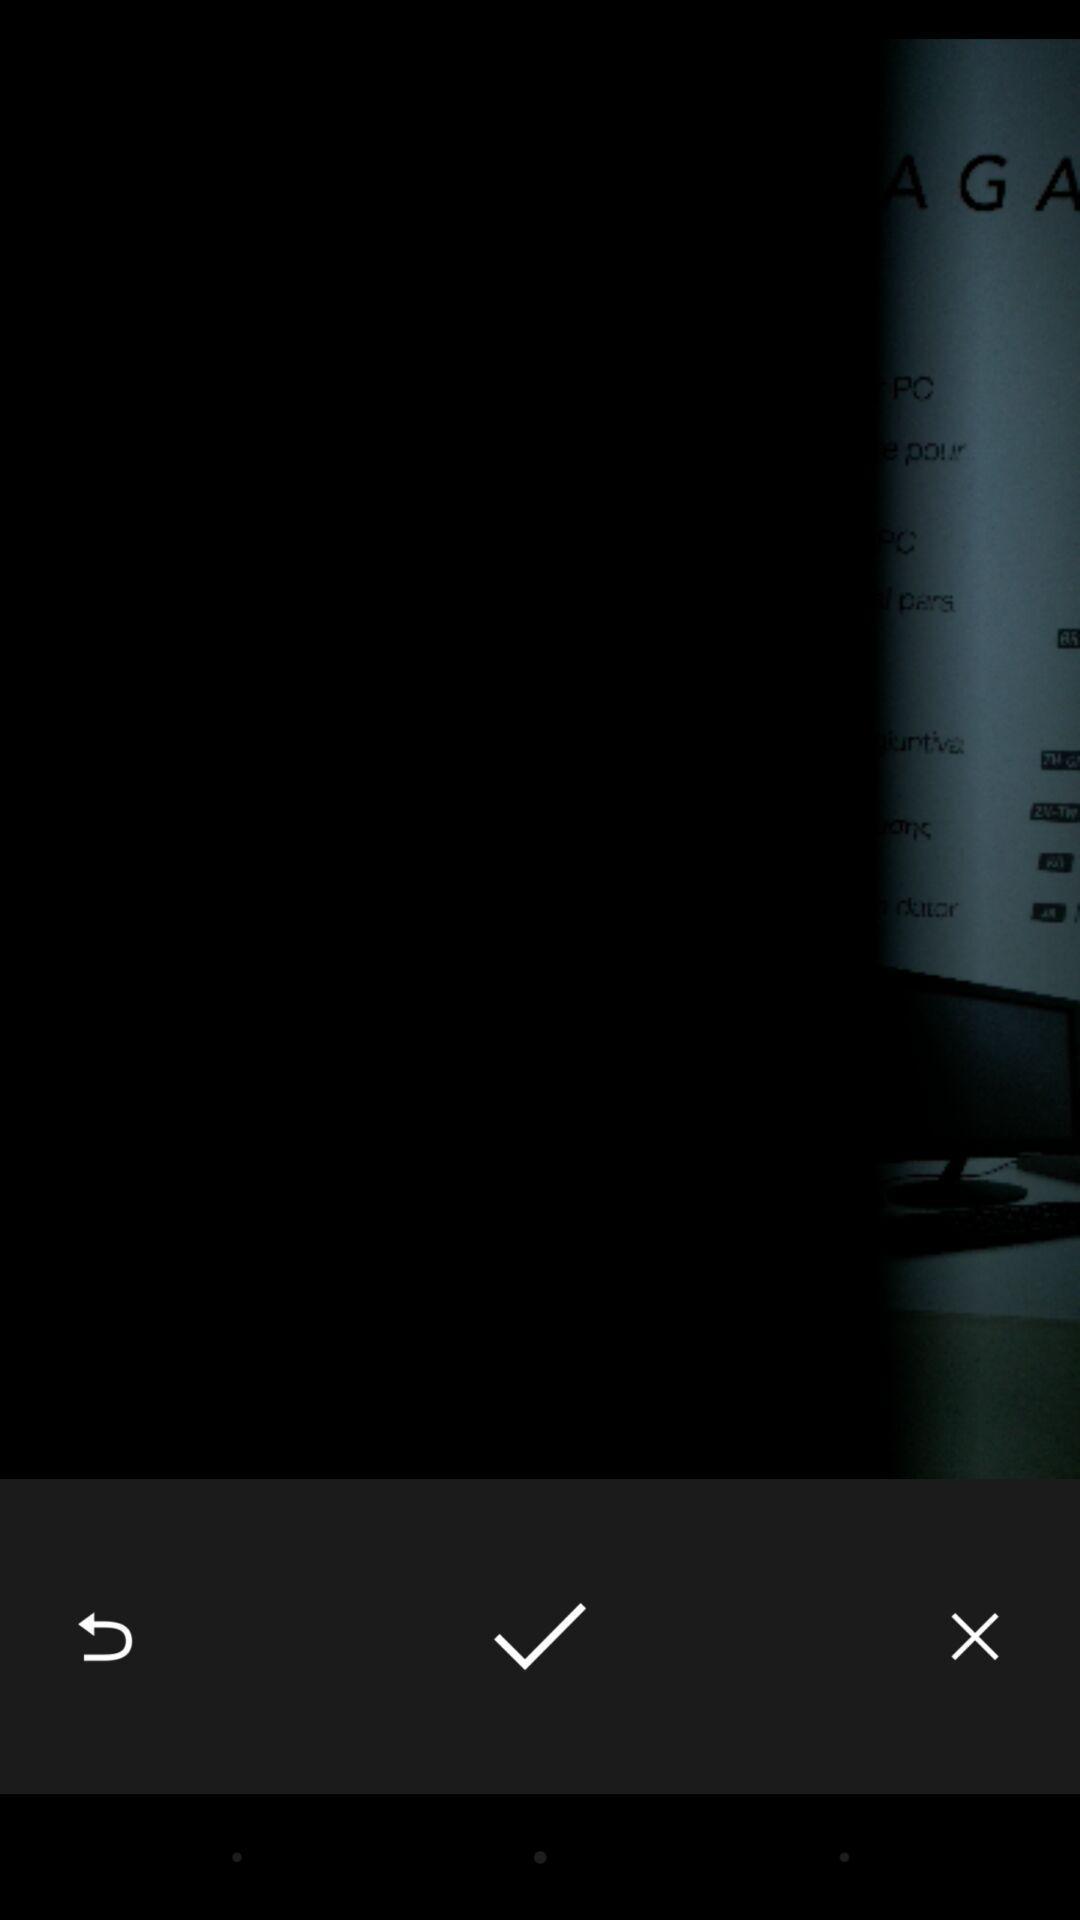What can you discern from this picture? Page displaying an image with options. 